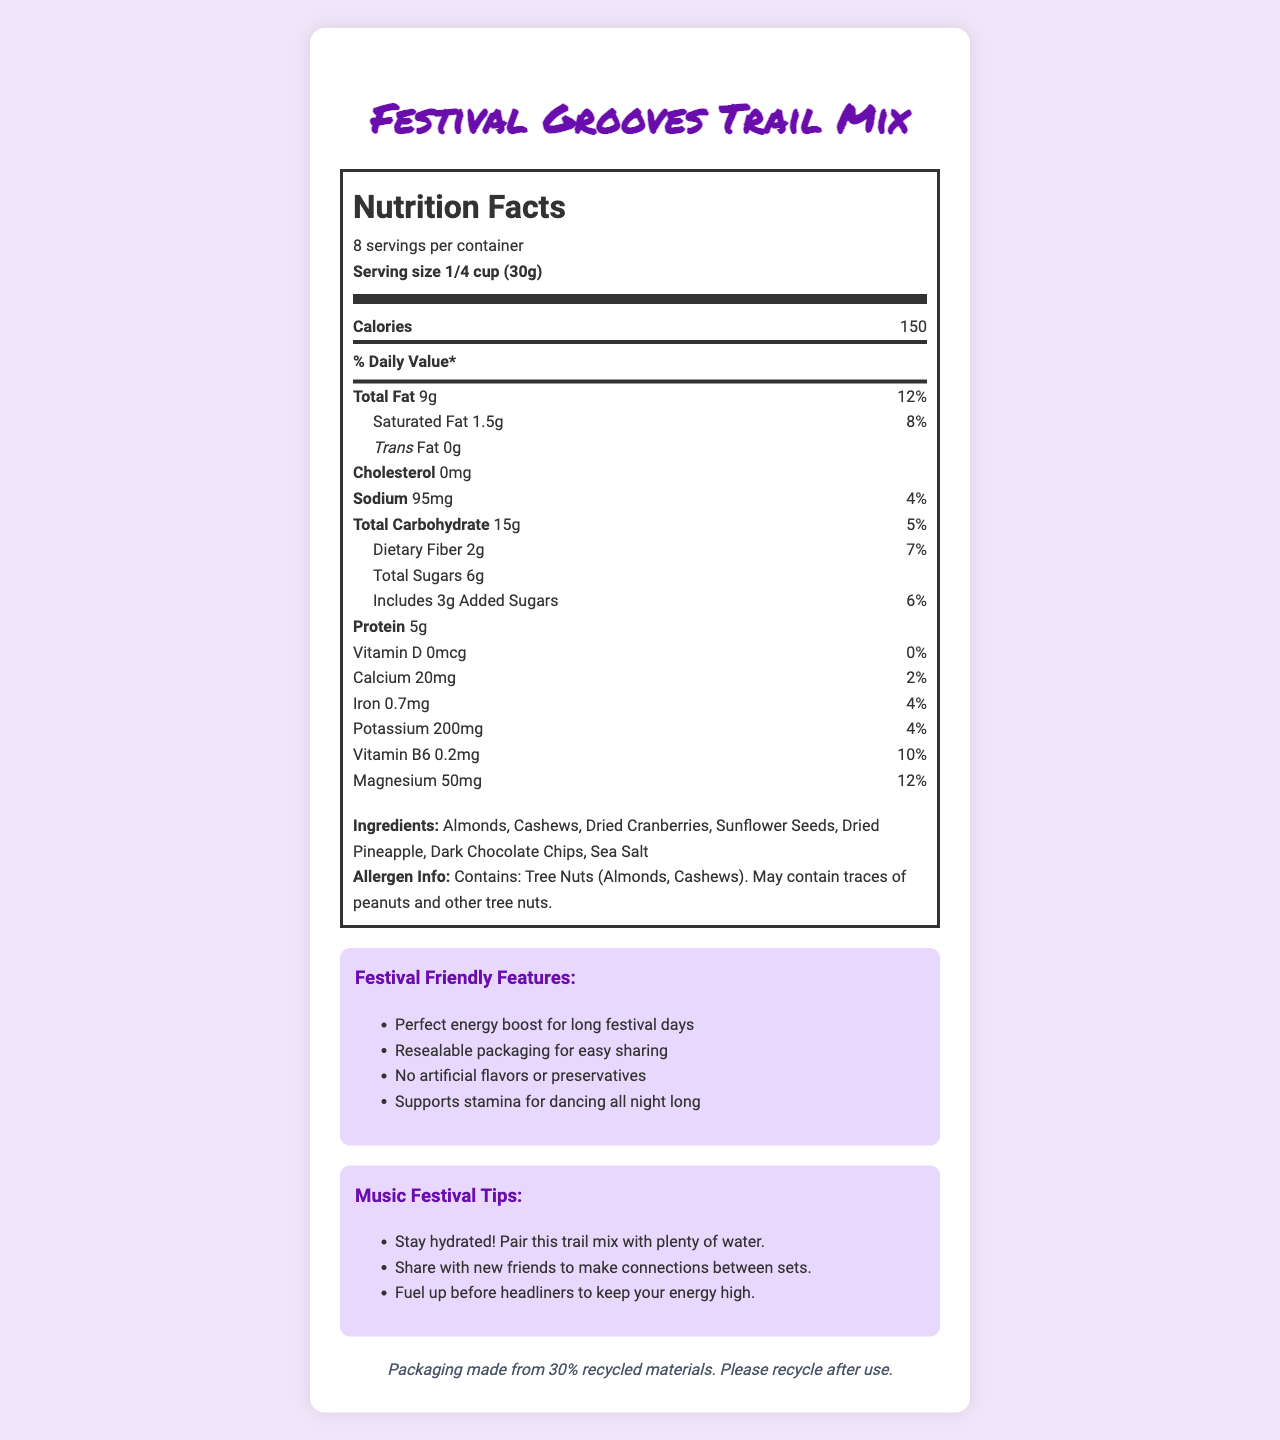what is the serving size for the Festival Grooves Trail Mix? The serving size is clearly listed in the "Nutrition Facts" section of the document as "1/4 cup (30g)."
Answer: 1/4 cup (30g) how many calories are in one serving? The number of calories per serving is listed in the "Nutrition Facts" section.
Answer: 150 how much protein does each serving contain? The document states that one serving contains 5g of protein.
Answer: 5g what are the ingredients of the trail mix? The ingredients are listed in a distinct section under "Ingredients."
Answer: Almonds, Cashews, Dried Cranberries, Sunflower Seeds, Dried Pineapple, Dark Chocolate Chips, Sea Salt does this product contain any artificial flavors or preservatives? Under "Marketing Claims," one of the points claims "No artificial flavors or preservatives."
Answer: No what is the daily value percentage of total fat per serving? The daily value percentage for total fat is listed next to the total fat amount (9g) as 12%.
Answer: 12% how many servings are in each container? The document mentions that there are 8 servings per container.
Answer: 8 is the packaging environmentally friendly? The sustainability note mentions that the packaging is made from 30% recycled materials and encourages recycling after use.
Answer: Yes does the trail mix contain peanuts? The allergen info section states that it may contain traces of peanuts and other tree nuts.
Answer: May contain traces Which of the following nutrients have a daily value percentage of 4%? A. Total Fat B. Sodium C. Magnesium The document lists the daily value percentages of each nutrient, and only Sodium has a daily value of 4%.
Answer: B how much magnesium is there per serving? A. 50mg B. 20mg C. 200mg D. 95mg The document lists magnesium at 50mg per serving.
Answer: A can I eat this product if I'm avoiding gluten? The document does not mention anything about gluten content, so we cannot determine if it is gluten-free.
Answer: Not enough information does this trail mix support stamina for dancing all night long? One of the marketing claims explicitly states "Supports stamina for dancing all night long."
Answer: Yes Summarize the main idea of the Festival Grooves Trail Mix document. The document is a detailed Nutrition Facts Label and marketing sheet for a trail mix tailored to music festival attendees, emphasizing its nutritional benefits, ingredients, allergen information, sustainability aspects, and festival-related tips.
Answer: The Festival Grooves Trail Mix is a nutritious snack designed for music festival attendees, offering a mix of almonds, cashews, dried cranberries, sunflower seeds, dried pineapple, dark chocolate chips, and sea salt. It is marketed as an energy-boosting snack without artificial flavors or preservatives. The packaging is environmentally friendly, containing 30% recycled materials. The product provides various essential nutrients and includes tips for staying hydrated and making the most of a festival experience. 